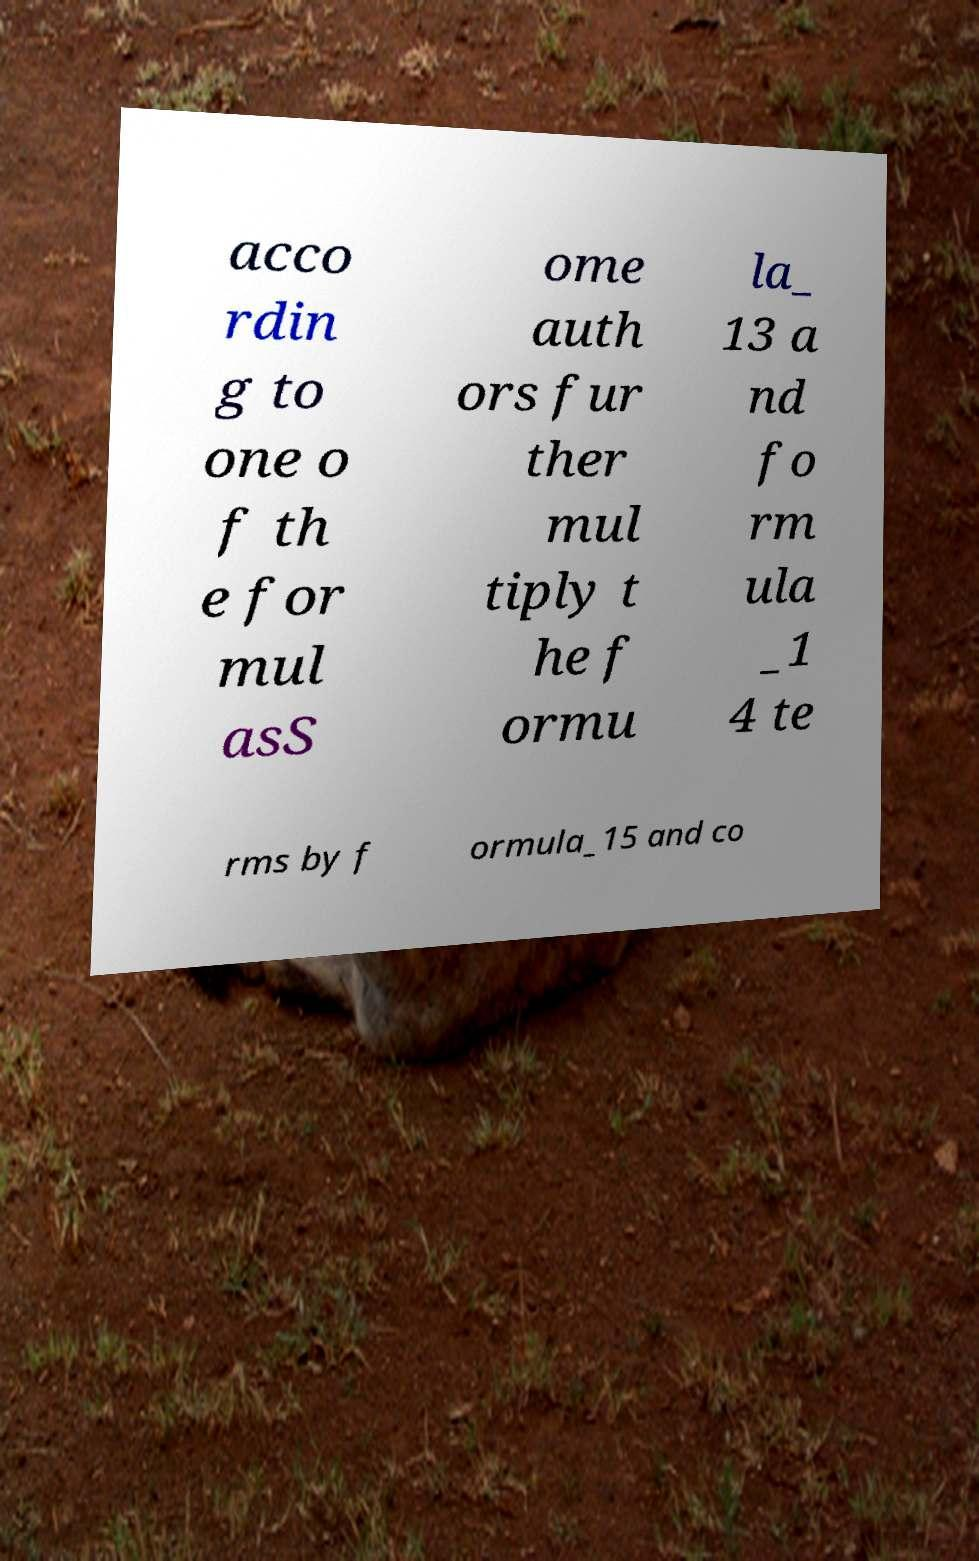Please read and relay the text visible in this image. What does it say? acco rdin g to one o f th e for mul asS ome auth ors fur ther mul tiply t he f ormu la_ 13 a nd fo rm ula _1 4 te rms by f ormula_15 and co 